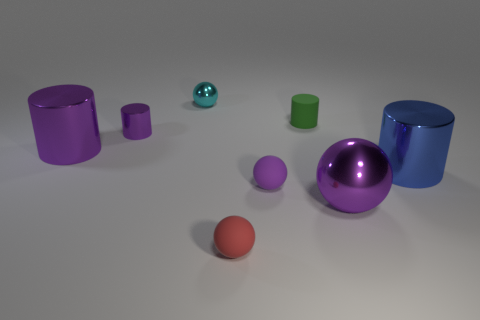Add 1 purple metallic objects. How many objects exist? 9 Subtract 1 cyan balls. How many objects are left? 7 Subtract all tiny purple rubber objects. Subtract all cyan metal things. How many objects are left? 6 Add 2 tiny purple matte things. How many tiny purple matte things are left? 3 Add 1 tiny red matte balls. How many tiny red matte balls exist? 2 